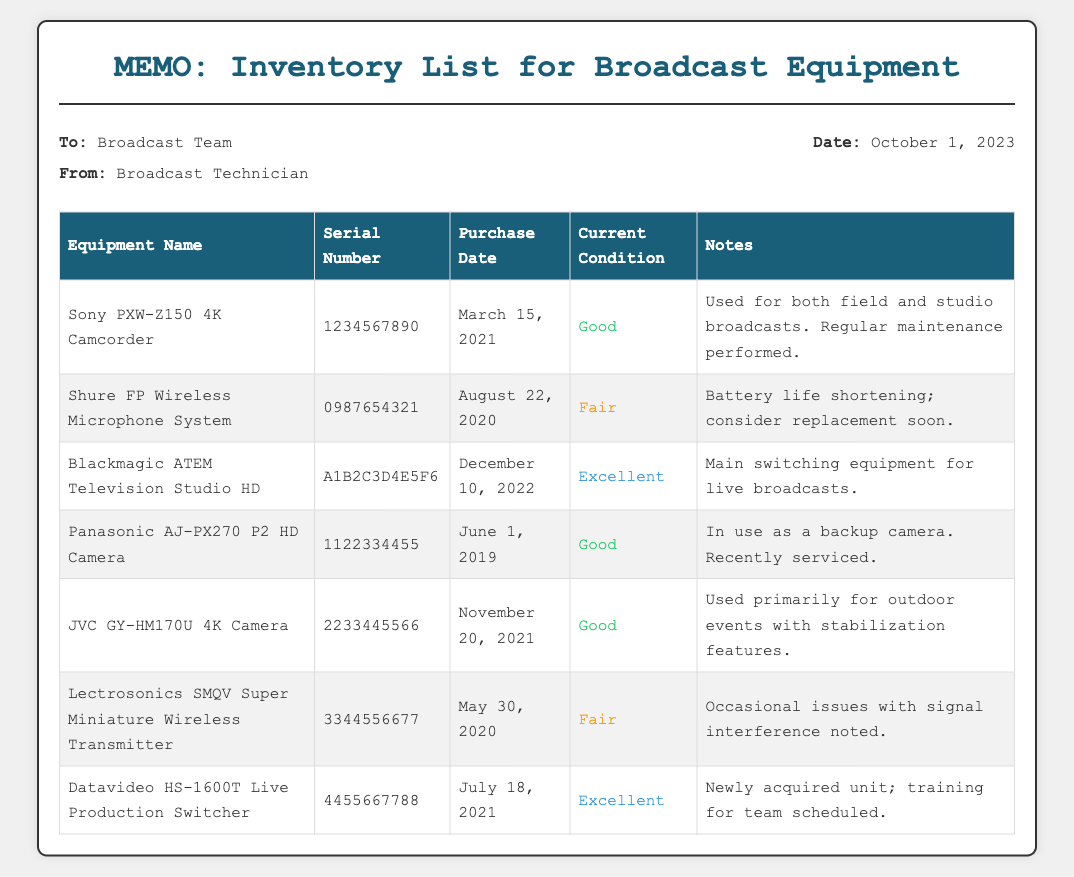What is the purchase date of the Sony PXW-Z150 4K Camcorder? The purchase date is listed in the document next to the equipment name.
Answer: March 15, 2021 What is the serial number of the Shure FP Wireless Microphone System? The serial number can be found in the corresponding row for the Shure FP Wireless Microphone System.
Answer: 0987654321 How many pieces of equipment are listed in the inventory? The total number of rows under the equipment section indicates the count of different equipment listed.
Answer: 7 What is the current condition of the Blackmagic ATEM Television Studio HD? The current condition is noted in the document next to the respective equipment's name.
Answer: Excellent What issues are noted with the Lectrosonics SMQV Super Miniature Wireless Transmitter? The document mentions specific issues associated with the equipment, providing insight into its performance.
Answer: Signal interference What is the date of the memo? The date is mentioned in the details section at the top of the memo.
Answer: October 1, 2023 Which camera is used primarily for outdoor events? This information is available under the specific equipment's description in the table.
Answer: JVC GY-HM170U 4K Camera 